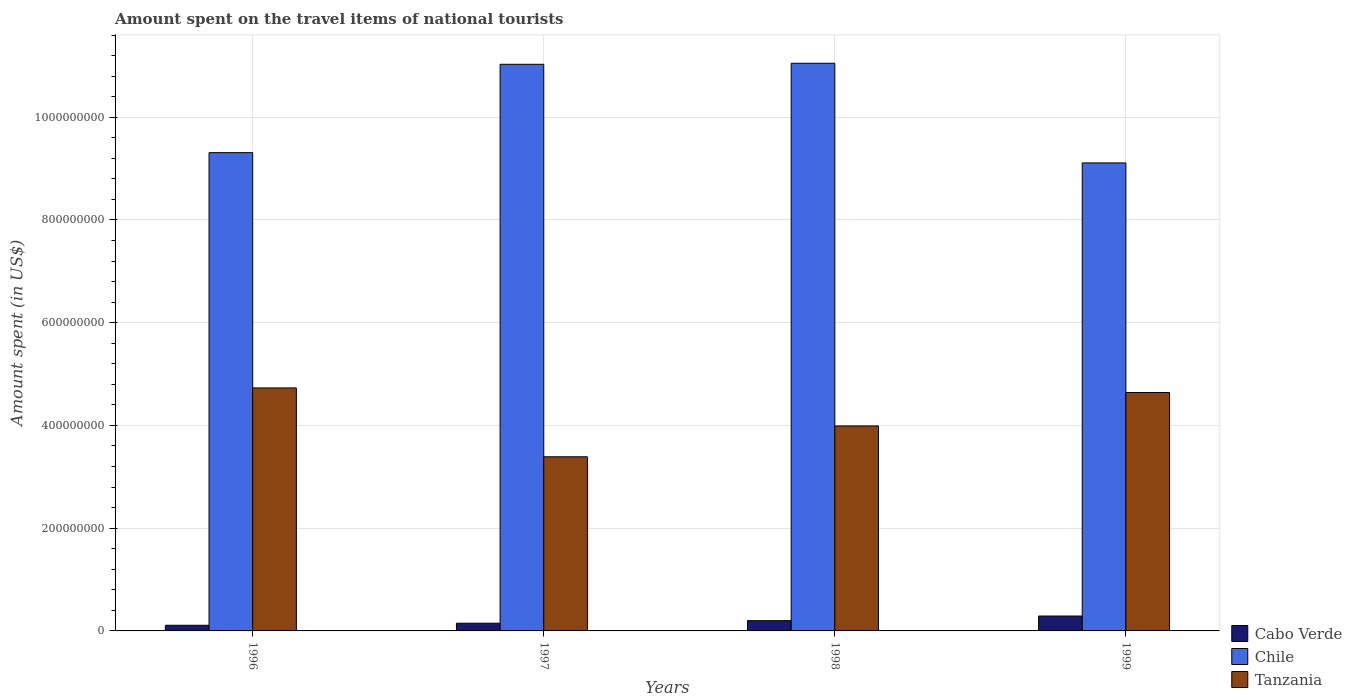In how many cases, is the number of bars for a given year not equal to the number of legend labels?
Provide a succinct answer. 0. What is the amount spent on the travel items of national tourists in Tanzania in 1998?
Ensure brevity in your answer.  3.99e+08. Across all years, what is the maximum amount spent on the travel items of national tourists in Chile?
Your answer should be very brief. 1.10e+09. Across all years, what is the minimum amount spent on the travel items of national tourists in Tanzania?
Your answer should be very brief. 3.39e+08. In which year was the amount spent on the travel items of national tourists in Cabo Verde maximum?
Your answer should be compact. 1999. In which year was the amount spent on the travel items of national tourists in Chile minimum?
Make the answer very short. 1999. What is the total amount spent on the travel items of national tourists in Tanzania in the graph?
Your answer should be compact. 1.68e+09. What is the difference between the amount spent on the travel items of national tourists in Tanzania in 1998 and that in 1999?
Provide a short and direct response. -6.50e+07. What is the difference between the amount spent on the travel items of national tourists in Chile in 1997 and the amount spent on the travel items of national tourists in Cabo Verde in 1998?
Provide a succinct answer. 1.08e+09. What is the average amount spent on the travel items of national tourists in Tanzania per year?
Ensure brevity in your answer.  4.19e+08. In the year 1998, what is the difference between the amount spent on the travel items of national tourists in Chile and amount spent on the travel items of national tourists in Cabo Verde?
Provide a short and direct response. 1.08e+09. In how many years, is the amount spent on the travel items of national tourists in Tanzania greater than 480000000 US$?
Offer a very short reply. 0. What is the ratio of the amount spent on the travel items of national tourists in Chile in 1997 to that in 1999?
Provide a short and direct response. 1.21. Is the amount spent on the travel items of national tourists in Chile in 1997 less than that in 1999?
Make the answer very short. No. Is the difference between the amount spent on the travel items of national tourists in Chile in 1996 and 1997 greater than the difference between the amount spent on the travel items of national tourists in Cabo Verde in 1996 and 1997?
Offer a terse response. No. What is the difference between the highest and the second highest amount spent on the travel items of national tourists in Chile?
Offer a terse response. 2.00e+06. What is the difference between the highest and the lowest amount spent on the travel items of national tourists in Chile?
Give a very brief answer. 1.94e+08. In how many years, is the amount spent on the travel items of national tourists in Cabo Verde greater than the average amount spent on the travel items of national tourists in Cabo Verde taken over all years?
Provide a succinct answer. 2. What does the 3rd bar from the left in 1998 represents?
Your answer should be very brief. Tanzania. What does the 3rd bar from the right in 1997 represents?
Offer a very short reply. Cabo Verde. How many bars are there?
Provide a short and direct response. 12. Are the values on the major ticks of Y-axis written in scientific E-notation?
Offer a very short reply. No. Does the graph contain any zero values?
Ensure brevity in your answer.  No. Does the graph contain grids?
Give a very brief answer. Yes. How are the legend labels stacked?
Give a very brief answer. Vertical. What is the title of the graph?
Ensure brevity in your answer.  Amount spent on the travel items of national tourists. What is the label or title of the X-axis?
Your answer should be compact. Years. What is the label or title of the Y-axis?
Provide a succinct answer. Amount spent (in US$). What is the Amount spent (in US$) of Cabo Verde in 1996?
Keep it short and to the point. 1.10e+07. What is the Amount spent (in US$) in Chile in 1996?
Offer a terse response. 9.31e+08. What is the Amount spent (in US$) in Tanzania in 1996?
Your answer should be compact. 4.73e+08. What is the Amount spent (in US$) in Cabo Verde in 1997?
Your answer should be compact. 1.50e+07. What is the Amount spent (in US$) in Chile in 1997?
Your response must be concise. 1.10e+09. What is the Amount spent (in US$) in Tanzania in 1997?
Make the answer very short. 3.39e+08. What is the Amount spent (in US$) in Cabo Verde in 1998?
Make the answer very short. 2.00e+07. What is the Amount spent (in US$) in Chile in 1998?
Your answer should be compact. 1.10e+09. What is the Amount spent (in US$) of Tanzania in 1998?
Make the answer very short. 3.99e+08. What is the Amount spent (in US$) of Cabo Verde in 1999?
Give a very brief answer. 2.90e+07. What is the Amount spent (in US$) of Chile in 1999?
Make the answer very short. 9.11e+08. What is the Amount spent (in US$) in Tanzania in 1999?
Your answer should be very brief. 4.64e+08. Across all years, what is the maximum Amount spent (in US$) in Cabo Verde?
Offer a very short reply. 2.90e+07. Across all years, what is the maximum Amount spent (in US$) in Chile?
Give a very brief answer. 1.10e+09. Across all years, what is the maximum Amount spent (in US$) of Tanzania?
Provide a succinct answer. 4.73e+08. Across all years, what is the minimum Amount spent (in US$) in Cabo Verde?
Offer a terse response. 1.10e+07. Across all years, what is the minimum Amount spent (in US$) of Chile?
Provide a succinct answer. 9.11e+08. Across all years, what is the minimum Amount spent (in US$) in Tanzania?
Your answer should be very brief. 3.39e+08. What is the total Amount spent (in US$) in Cabo Verde in the graph?
Ensure brevity in your answer.  7.50e+07. What is the total Amount spent (in US$) in Chile in the graph?
Provide a succinct answer. 4.05e+09. What is the total Amount spent (in US$) in Tanzania in the graph?
Make the answer very short. 1.68e+09. What is the difference between the Amount spent (in US$) in Cabo Verde in 1996 and that in 1997?
Offer a terse response. -4.00e+06. What is the difference between the Amount spent (in US$) of Chile in 1996 and that in 1997?
Make the answer very short. -1.72e+08. What is the difference between the Amount spent (in US$) of Tanzania in 1996 and that in 1997?
Provide a succinct answer. 1.34e+08. What is the difference between the Amount spent (in US$) of Cabo Verde in 1996 and that in 1998?
Ensure brevity in your answer.  -9.00e+06. What is the difference between the Amount spent (in US$) of Chile in 1996 and that in 1998?
Your response must be concise. -1.74e+08. What is the difference between the Amount spent (in US$) in Tanzania in 1996 and that in 1998?
Your answer should be compact. 7.40e+07. What is the difference between the Amount spent (in US$) in Cabo Verde in 1996 and that in 1999?
Ensure brevity in your answer.  -1.80e+07. What is the difference between the Amount spent (in US$) of Tanzania in 1996 and that in 1999?
Offer a terse response. 9.00e+06. What is the difference between the Amount spent (in US$) in Cabo Verde in 1997 and that in 1998?
Provide a succinct answer. -5.00e+06. What is the difference between the Amount spent (in US$) in Chile in 1997 and that in 1998?
Provide a short and direct response. -2.00e+06. What is the difference between the Amount spent (in US$) of Tanzania in 1997 and that in 1998?
Ensure brevity in your answer.  -6.00e+07. What is the difference between the Amount spent (in US$) of Cabo Verde in 1997 and that in 1999?
Make the answer very short. -1.40e+07. What is the difference between the Amount spent (in US$) of Chile in 1997 and that in 1999?
Your response must be concise. 1.92e+08. What is the difference between the Amount spent (in US$) in Tanzania in 1997 and that in 1999?
Keep it short and to the point. -1.25e+08. What is the difference between the Amount spent (in US$) in Cabo Verde in 1998 and that in 1999?
Your response must be concise. -9.00e+06. What is the difference between the Amount spent (in US$) in Chile in 1998 and that in 1999?
Your answer should be compact. 1.94e+08. What is the difference between the Amount spent (in US$) in Tanzania in 1998 and that in 1999?
Ensure brevity in your answer.  -6.50e+07. What is the difference between the Amount spent (in US$) of Cabo Verde in 1996 and the Amount spent (in US$) of Chile in 1997?
Keep it short and to the point. -1.09e+09. What is the difference between the Amount spent (in US$) in Cabo Verde in 1996 and the Amount spent (in US$) in Tanzania in 1997?
Your answer should be compact. -3.28e+08. What is the difference between the Amount spent (in US$) in Chile in 1996 and the Amount spent (in US$) in Tanzania in 1997?
Provide a succinct answer. 5.92e+08. What is the difference between the Amount spent (in US$) of Cabo Verde in 1996 and the Amount spent (in US$) of Chile in 1998?
Keep it short and to the point. -1.09e+09. What is the difference between the Amount spent (in US$) in Cabo Verde in 1996 and the Amount spent (in US$) in Tanzania in 1998?
Offer a very short reply. -3.88e+08. What is the difference between the Amount spent (in US$) of Chile in 1996 and the Amount spent (in US$) of Tanzania in 1998?
Give a very brief answer. 5.32e+08. What is the difference between the Amount spent (in US$) in Cabo Verde in 1996 and the Amount spent (in US$) in Chile in 1999?
Ensure brevity in your answer.  -9.00e+08. What is the difference between the Amount spent (in US$) of Cabo Verde in 1996 and the Amount spent (in US$) of Tanzania in 1999?
Make the answer very short. -4.53e+08. What is the difference between the Amount spent (in US$) in Chile in 1996 and the Amount spent (in US$) in Tanzania in 1999?
Keep it short and to the point. 4.67e+08. What is the difference between the Amount spent (in US$) in Cabo Verde in 1997 and the Amount spent (in US$) in Chile in 1998?
Provide a succinct answer. -1.09e+09. What is the difference between the Amount spent (in US$) in Cabo Verde in 1997 and the Amount spent (in US$) in Tanzania in 1998?
Give a very brief answer. -3.84e+08. What is the difference between the Amount spent (in US$) of Chile in 1997 and the Amount spent (in US$) of Tanzania in 1998?
Ensure brevity in your answer.  7.04e+08. What is the difference between the Amount spent (in US$) in Cabo Verde in 1997 and the Amount spent (in US$) in Chile in 1999?
Offer a terse response. -8.96e+08. What is the difference between the Amount spent (in US$) of Cabo Verde in 1997 and the Amount spent (in US$) of Tanzania in 1999?
Give a very brief answer. -4.49e+08. What is the difference between the Amount spent (in US$) of Chile in 1997 and the Amount spent (in US$) of Tanzania in 1999?
Keep it short and to the point. 6.39e+08. What is the difference between the Amount spent (in US$) of Cabo Verde in 1998 and the Amount spent (in US$) of Chile in 1999?
Your response must be concise. -8.91e+08. What is the difference between the Amount spent (in US$) in Cabo Verde in 1998 and the Amount spent (in US$) in Tanzania in 1999?
Your response must be concise. -4.44e+08. What is the difference between the Amount spent (in US$) of Chile in 1998 and the Amount spent (in US$) of Tanzania in 1999?
Keep it short and to the point. 6.41e+08. What is the average Amount spent (in US$) of Cabo Verde per year?
Offer a very short reply. 1.88e+07. What is the average Amount spent (in US$) of Chile per year?
Your answer should be very brief. 1.01e+09. What is the average Amount spent (in US$) of Tanzania per year?
Provide a short and direct response. 4.19e+08. In the year 1996, what is the difference between the Amount spent (in US$) in Cabo Verde and Amount spent (in US$) in Chile?
Your response must be concise. -9.20e+08. In the year 1996, what is the difference between the Amount spent (in US$) in Cabo Verde and Amount spent (in US$) in Tanzania?
Make the answer very short. -4.62e+08. In the year 1996, what is the difference between the Amount spent (in US$) in Chile and Amount spent (in US$) in Tanzania?
Give a very brief answer. 4.58e+08. In the year 1997, what is the difference between the Amount spent (in US$) in Cabo Verde and Amount spent (in US$) in Chile?
Keep it short and to the point. -1.09e+09. In the year 1997, what is the difference between the Amount spent (in US$) of Cabo Verde and Amount spent (in US$) of Tanzania?
Offer a terse response. -3.24e+08. In the year 1997, what is the difference between the Amount spent (in US$) in Chile and Amount spent (in US$) in Tanzania?
Keep it short and to the point. 7.64e+08. In the year 1998, what is the difference between the Amount spent (in US$) of Cabo Verde and Amount spent (in US$) of Chile?
Provide a short and direct response. -1.08e+09. In the year 1998, what is the difference between the Amount spent (in US$) in Cabo Verde and Amount spent (in US$) in Tanzania?
Provide a succinct answer. -3.79e+08. In the year 1998, what is the difference between the Amount spent (in US$) in Chile and Amount spent (in US$) in Tanzania?
Make the answer very short. 7.06e+08. In the year 1999, what is the difference between the Amount spent (in US$) in Cabo Verde and Amount spent (in US$) in Chile?
Offer a terse response. -8.82e+08. In the year 1999, what is the difference between the Amount spent (in US$) in Cabo Verde and Amount spent (in US$) in Tanzania?
Give a very brief answer. -4.35e+08. In the year 1999, what is the difference between the Amount spent (in US$) of Chile and Amount spent (in US$) of Tanzania?
Your answer should be very brief. 4.47e+08. What is the ratio of the Amount spent (in US$) in Cabo Verde in 1996 to that in 1997?
Provide a short and direct response. 0.73. What is the ratio of the Amount spent (in US$) of Chile in 1996 to that in 1997?
Offer a terse response. 0.84. What is the ratio of the Amount spent (in US$) of Tanzania in 1996 to that in 1997?
Offer a terse response. 1.4. What is the ratio of the Amount spent (in US$) of Cabo Verde in 1996 to that in 1998?
Make the answer very short. 0.55. What is the ratio of the Amount spent (in US$) in Chile in 1996 to that in 1998?
Your response must be concise. 0.84. What is the ratio of the Amount spent (in US$) in Tanzania in 1996 to that in 1998?
Ensure brevity in your answer.  1.19. What is the ratio of the Amount spent (in US$) in Cabo Verde in 1996 to that in 1999?
Offer a terse response. 0.38. What is the ratio of the Amount spent (in US$) of Tanzania in 1996 to that in 1999?
Provide a succinct answer. 1.02. What is the ratio of the Amount spent (in US$) of Tanzania in 1997 to that in 1998?
Give a very brief answer. 0.85. What is the ratio of the Amount spent (in US$) of Cabo Verde in 1997 to that in 1999?
Provide a succinct answer. 0.52. What is the ratio of the Amount spent (in US$) in Chile in 1997 to that in 1999?
Make the answer very short. 1.21. What is the ratio of the Amount spent (in US$) of Tanzania in 1997 to that in 1999?
Offer a terse response. 0.73. What is the ratio of the Amount spent (in US$) of Cabo Verde in 1998 to that in 1999?
Your answer should be very brief. 0.69. What is the ratio of the Amount spent (in US$) in Chile in 1998 to that in 1999?
Your answer should be compact. 1.21. What is the ratio of the Amount spent (in US$) of Tanzania in 1998 to that in 1999?
Keep it short and to the point. 0.86. What is the difference between the highest and the second highest Amount spent (in US$) in Cabo Verde?
Offer a terse response. 9.00e+06. What is the difference between the highest and the second highest Amount spent (in US$) in Chile?
Your response must be concise. 2.00e+06. What is the difference between the highest and the second highest Amount spent (in US$) of Tanzania?
Give a very brief answer. 9.00e+06. What is the difference between the highest and the lowest Amount spent (in US$) of Cabo Verde?
Make the answer very short. 1.80e+07. What is the difference between the highest and the lowest Amount spent (in US$) of Chile?
Your answer should be very brief. 1.94e+08. What is the difference between the highest and the lowest Amount spent (in US$) in Tanzania?
Your answer should be very brief. 1.34e+08. 